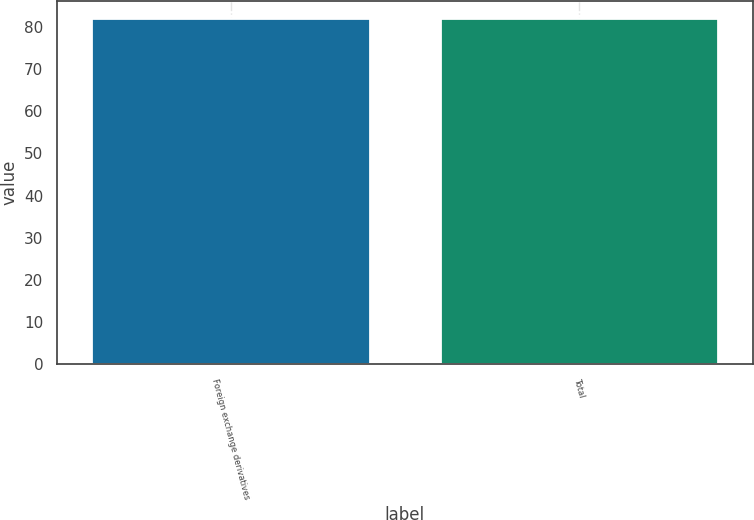<chart> <loc_0><loc_0><loc_500><loc_500><bar_chart><fcel>Foreign exchange derivatives<fcel>Total<nl><fcel>82<fcel>82.1<nl></chart> 